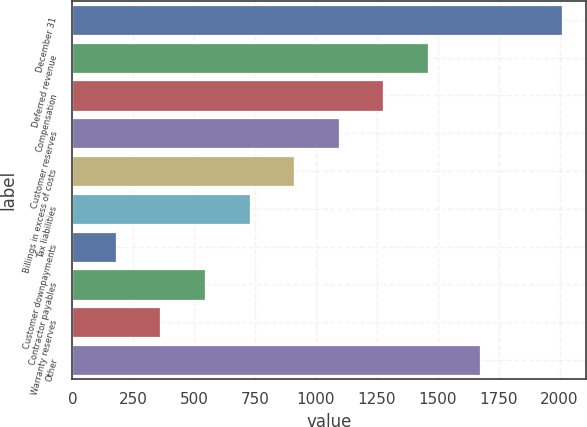Convert chart. <chart><loc_0><loc_0><loc_500><loc_500><bar_chart><fcel>December 31<fcel>Deferred revenue<fcel>Compensation<fcel>Customer reserves<fcel>Billings in excess of costs<fcel>Tax liabilities<fcel>Customer downpayments<fcel>Contractor payables<fcel>Warranty reserves<fcel>Other<nl><fcel>2009<fcel>1459.7<fcel>1276.6<fcel>1093.5<fcel>910.4<fcel>727.3<fcel>178<fcel>544.2<fcel>361.1<fcel>1675<nl></chart> 